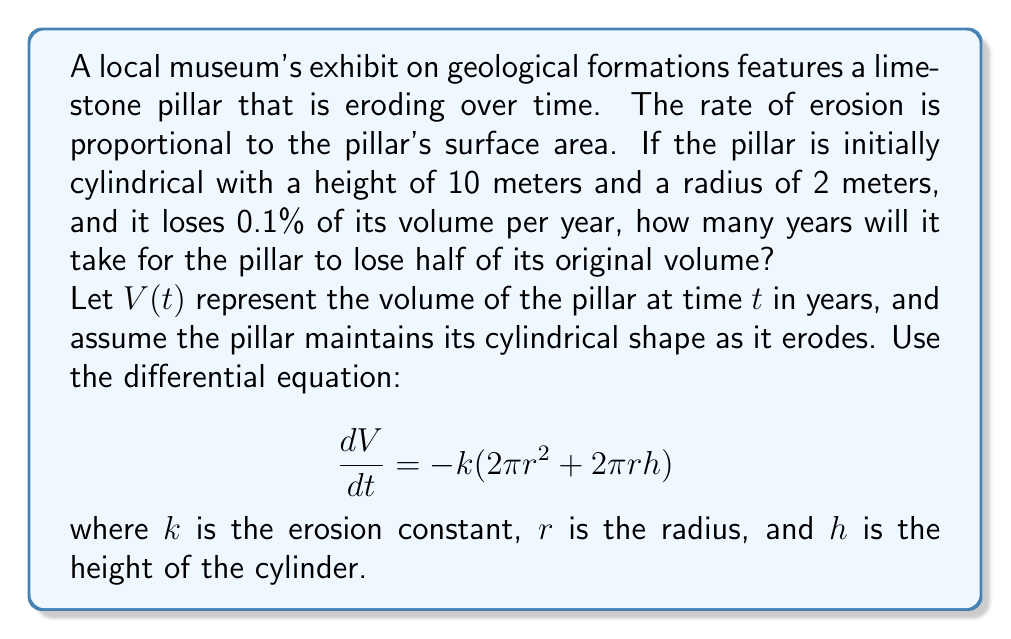Could you help me with this problem? Let's approach this step-by-step:

1) First, we need to find the initial volume $V_0$:
   $$V_0 = \pi r^2 h = \pi \cdot 2^2 \cdot 10 = 40\pi \text{ m}^3$$

2) We're told that the pillar loses 0.1% of its volume per year. This means:
   $$\frac{dV}{dt} = -0.001V$$

3) Comparing this to the given differential equation:
   $$\frac{dV}{dt} = -k(2\pi r^2 + 2\pi rh) = -0.001V$$

4) We can solve for $k$ using the initial dimensions:
   $$0.001 \cdot 40\pi = k(2\pi \cdot 2^2 + 2\pi \cdot 2 \cdot 10)$$
   $$0.04\pi = k(8\pi + 40\pi)$$
   $$k = \frac{0.04\pi}{48\pi} = \frac{1}{1200}$$

5) Now, we can set up the differential equation:
   $$\frac{dV}{dt} = -0.001V$$

6) This is a separable differential equation. Solving it:
   $$\int \frac{dV}{V} = -0.001 \int dt$$
   $$\ln(V) = -0.001t + C$$

7) Using the initial condition $V(0) = 40\pi$:
   $$\ln(40\pi) = C$$

8) Therefore, the solution is:
   $$V(t) = 40\pi e^{-0.001t}$$

9) We want to find when $V(t) = \frac{1}{2}V_0 = 20\pi$:
   $$20\pi = 40\pi e^{-0.001t}$$
   $$\frac{1}{2} = e^{-0.001t}$$
   $$\ln(\frac{1}{2}) = -0.001t$$
   $$t = \frac{\ln(2)}{0.001} \approx 693.15$$

Therefore, it will take approximately 693 years for the pillar to lose half of its original volume.
Answer: 693 years 